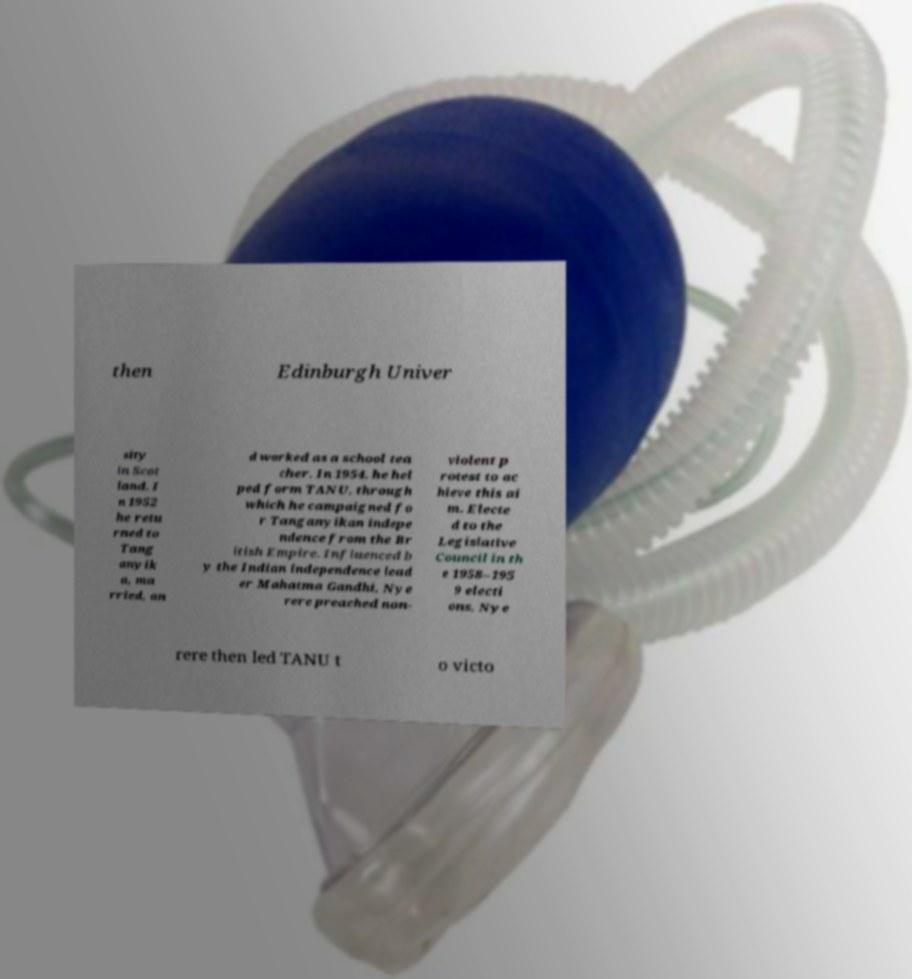There's text embedded in this image that I need extracted. Can you transcribe it verbatim? then Edinburgh Univer sity in Scot land. I n 1952 he retu rned to Tang anyik a, ma rried, an d worked as a school tea cher. In 1954, he hel ped form TANU, through which he campaigned fo r Tanganyikan indepe ndence from the Br itish Empire. Influenced b y the Indian independence lead er Mahatma Gandhi, Nye rere preached non- violent p rotest to ac hieve this ai m. Electe d to the Legislative Council in th e 1958–195 9 electi ons, Nye rere then led TANU t o victo 